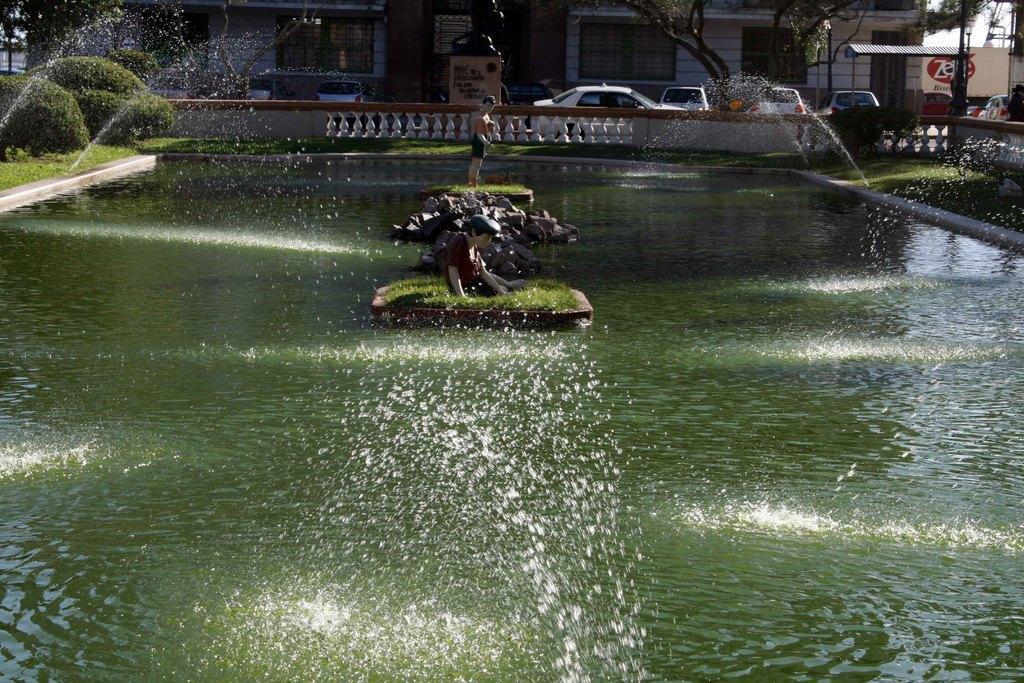Could you give a brief overview of what you see in this image? In this image we can see buildings, shed, motor vehicles on the floor, fountains, bushes, sky, trees, grass, statues and stones. 